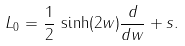Convert formula to latex. <formula><loc_0><loc_0><loc_500><loc_500>L _ { 0 } = \frac { 1 } { 2 } \, \sinh ( 2 w ) \frac { d } { d w } + s .</formula> 